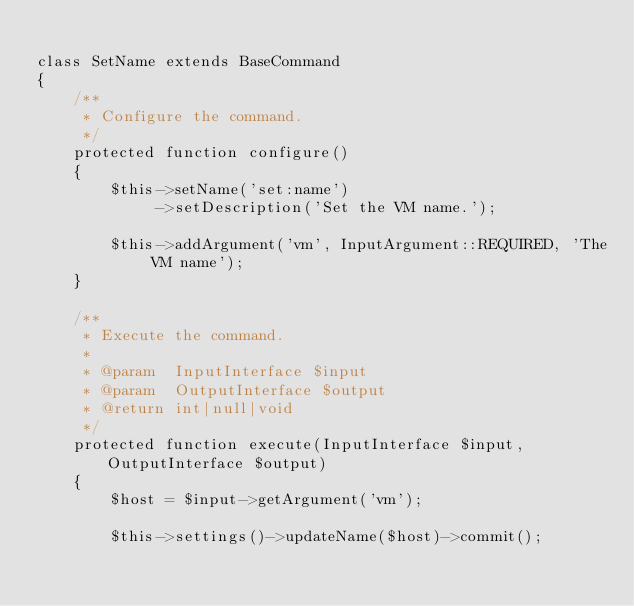Convert code to text. <code><loc_0><loc_0><loc_500><loc_500><_PHP_>
class SetName extends BaseCommand
{
    /**
     * Configure the command.
     */
    protected function configure()
    {
        $this->setName('set:name')
             ->setDescription('Set the VM name.');

        $this->addArgument('vm', InputArgument::REQUIRED, 'The VM name');
    }

    /**
     * Execute the command.
     *
     * @param  InputInterface $input
     * @param  OutputInterface $output
     * @return int|null|void
     */
    protected function execute(InputInterface $input, OutputInterface $output)
    {
        $host = $input->getArgument('vm');

        $this->settings()->updateName($host)->commit();
</code> 